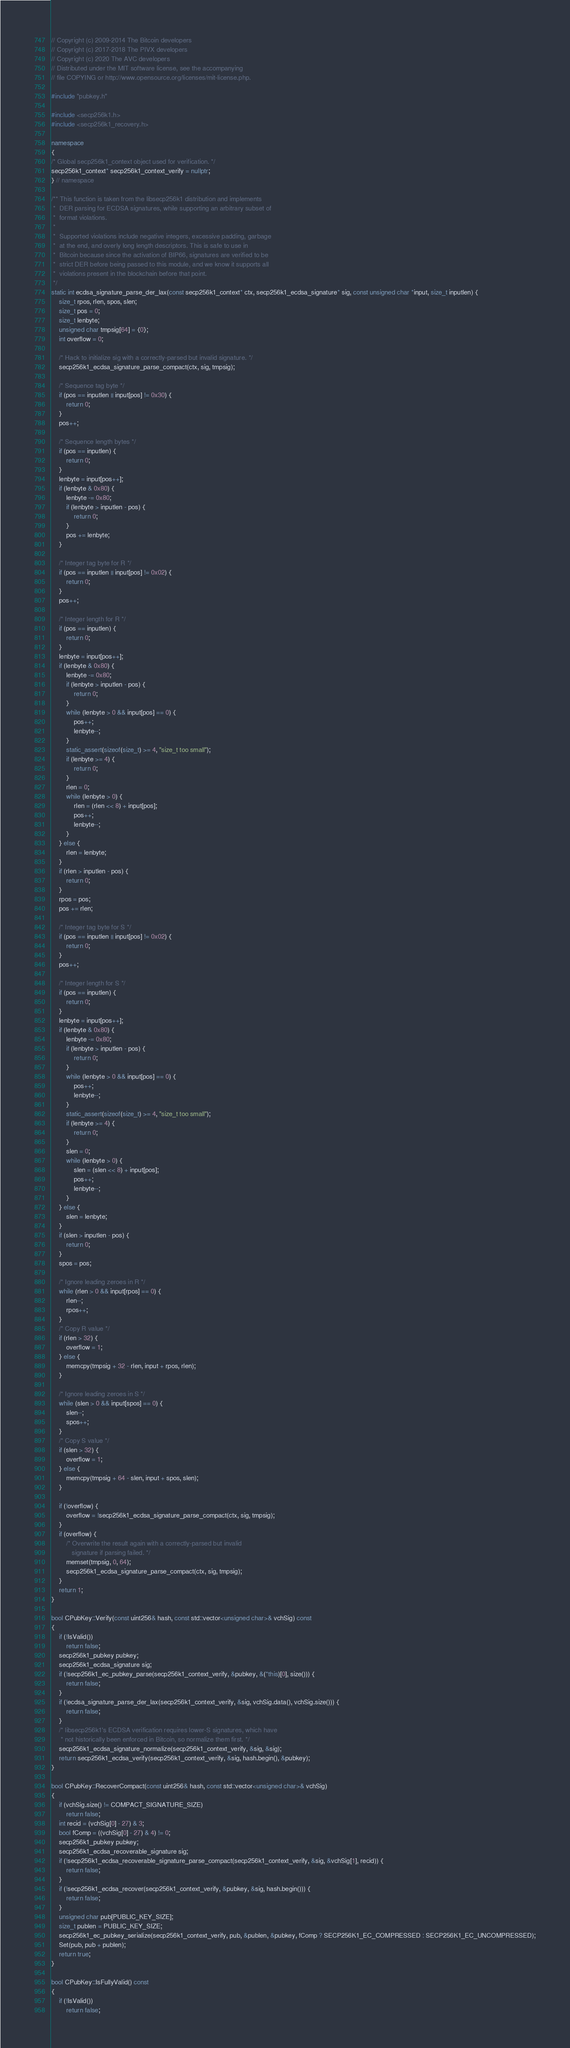Convert code to text. <code><loc_0><loc_0><loc_500><loc_500><_C++_>// Copyright (c) 2009-2014 The Bitcoin developers
// Copyright (c) 2017-2018 The PIVX developers
// Copyright (c) 2020 The AVC developers
// Distributed under the MIT software license, see the accompanying
// file COPYING or http://www.opensource.org/licenses/mit-license.php.

#include "pubkey.h"

#include <secp256k1.h>
#include <secp256k1_recovery.h>

namespace
{
/* Global secp256k1_context object used for verification. */
secp256k1_context* secp256k1_context_verify = nullptr;
} // namespace

/** This function is taken from the libsecp256k1 distribution and implements
 *  DER parsing for ECDSA signatures, while supporting an arbitrary subset of
 *  format violations.
 *
 *  Supported violations include negative integers, excessive padding, garbage
 *  at the end, and overly long length descriptors. This is safe to use in
 *  Bitcoin because since the activation of BIP66, signatures are verified to be
 *  strict DER before being passed to this module, and we know it supports all
 *  violations present in the blockchain before that point.
 */
static int ecdsa_signature_parse_der_lax(const secp256k1_context* ctx, secp256k1_ecdsa_signature* sig, const unsigned char *input, size_t inputlen) {
    size_t rpos, rlen, spos, slen;
    size_t pos = 0;
    size_t lenbyte;
    unsigned char tmpsig[64] = {0};
    int overflow = 0;

    /* Hack to initialize sig with a correctly-parsed but invalid signature. */
    secp256k1_ecdsa_signature_parse_compact(ctx, sig, tmpsig);

    /* Sequence tag byte */
    if (pos == inputlen || input[pos] != 0x30) {
        return 0;
    }
    pos++;

    /* Sequence length bytes */
    if (pos == inputlen) {
        return 0;
    }
    lenbyte = input[pos++];
    if (lenbyte & 0x80) {
        lenbyte -= 0x80;
        if (lenbyte > inputlen - pos) {
            return 0;
        }
        pos += lenbyte;
    }

    /* Integer tag byte for R */
    if (pos == inputlen || input[pos] != 0x02) {
        return 0;
    }
    pos++;

    /* Integer length for R */
    if (pos == inputlen) {
        return 0;
    }
    lenbyte = input[pos++];
    if (lenbyte & 0x80) {
        lenbyte -= 0x80;
        if (lenbyte > inputlen - pos) {
            return 0;
        }
        while (lenbyte > 0 && input[pos] == 0) {
            pos++;
            lenbyte--;
        }
        static_assert(sizeof(size_t) >= 4, "size_t too small");
        if (lenbyte >= 4) {
            return 0;
        }
        rlen = 0;
        while (lenbyte > 0) {
            rlen = (rlen << 8) + input[pos];
            pos++;
            lenbyte--;
        }
    } else {
        rlen = lenbyte;
    }
    if (rlen > inputlen - pos) {
        return 0;
    }
    rpos = pos;
    pos += rlen;

    /* Integer tag byte for S */
    if (pos == inputlen || input[pos] != 0x02) {
        return 0;
    }
    pos++;

    /* Integer length for S */
    if (pos == inputlen) {
        return 0;
    }
    lenbyte = input[pos++];
    if (lenbyte & 0x80) {
        lenbyte -= 0x80;
        if (lenbyte > inputlen - pos) {
            return 0;
        }
        while (lenbyte > 0 && input[pos] == 0) {
            pos++;
            lenbyte--;
        }
        static_assert(sizeof(size_t) >= 4, "size_t too small");
        if (lenbyte >= 4) {
            return 0;
        }
        slen = 0;
        while (lenbyte > 0) {
            slen = (slen << 8) + input[pos];
            pos++;
            lenbyte--;
        }
    } else {
        slen = lenbyte;
    }
    if (slen > inputlen - pos) {
        return 0;
    }
    spos = pos;

    /* Ignore leading zeroes in R */
    while (rlen > 0 && input[rpos] == 0) {
        rlen--;
        rpos++;
    }
    /* Copy R value */
    if (rlen > 32) {
        overflow = 1;
    } else {
        memcpy(tmpsig + 32 - rlen, input + rpos, rlen);
    }

    /* Ignore leading zeroes in S */
    while (slen > 0 && input[spos] == 0) {
        slen--;
        spos++;
    }
    /* Copy S value */
    if (slen > 32) {
        overflow = 1;
    } else {
        memcpy(tmpsig + 64 - slen, input + spos, slen);
    }

    if (!overflow) {
        overflow = !secp256k1_ecdsa_signature_parse_compact(ctx, sig, tmpsig);
    }
    if (overflow) {
        /* Overwrite the result again with a correctly-parsed but invalid
           signature if parsing failed. */
        memset(tmpsig, 0, 64);
        secp256k1_ecdsa_signature_parse_compact(ctx, sig, tmpsig);
    }
    return 1;
}

bool CPubKey::Verify(const uint256& hash, const std::vector<unsigned char>& vchSig) const
{
    if (!IsValid())
        return false;
    secp256k1_pubkey pubkey;
    secp256k1_ecdsa_signature sig;
    if (!secp256k1_ec_pubkey_parse(secp256k1_context_verify, &pubkey, &(*this)[0], size())) {
        return false;
    }
    if (!ecdsa_signature_parse_der_lax(secp256k1_context_verify, &sig, vchSig.data(), vchSig.size())) {
        return false;
    }
    /* libsecp256k1's ECDSA verification requires lower-S signatures, which have
     * not historically been enforced in Bitcoin, so normalize them first. */
    secp256k1_ecdsa_signature_normalize(secp256k1_context_verify, &sig, &sig);
    return secp256k1_ecdsa_verify(secp256k1_context_verify, &sig, hash.begin(), &pubkey);
}

bool CPubKey::RecoverCompact(const uint256& hash, const std::vector<unsigned char>& vchSig)
{
    if (vchSig.size() != COMPACT_SIGNATURE_SIZE)
        return false;
    int recid = (vchSig[0] - 27) & 3;
    bool fComp = ((vchSig[0] - 27) & 4) != 0;
    secp256k1_pubkey pubkey;
    secp256k1_ecdsa_recoverable_signature sig;
    if (!secp256k1_ecdsa_recoverable_signature_parse_compact(secp256k1_context_verify, &sig, &vchSig[1], recid)) {
        return false;
    }
    if (!secp256k1_ecdsa_recover(secp256k1_context_verify, &pubkey, &sig, hash.begin())) {
        return false;
    }
    unsigned char pub[PUBLIC_KEY_SIZE];
    size_t publen = PUBLIC_KEY_SIZE;
    secp256k1_ec_pubkey_serialize(secp256k1_context_verify, pub, &publen, &pubkey, fComp ? SECP256K1_EC_COMPRESSED : SECP256K1_EC_UNCOMPRESSED);
    Set(pub, pub + publen);
    return true;
}

bool CPubKey::IsFullyValid() const
{
    if (!IsValid())
        return false;</code> 